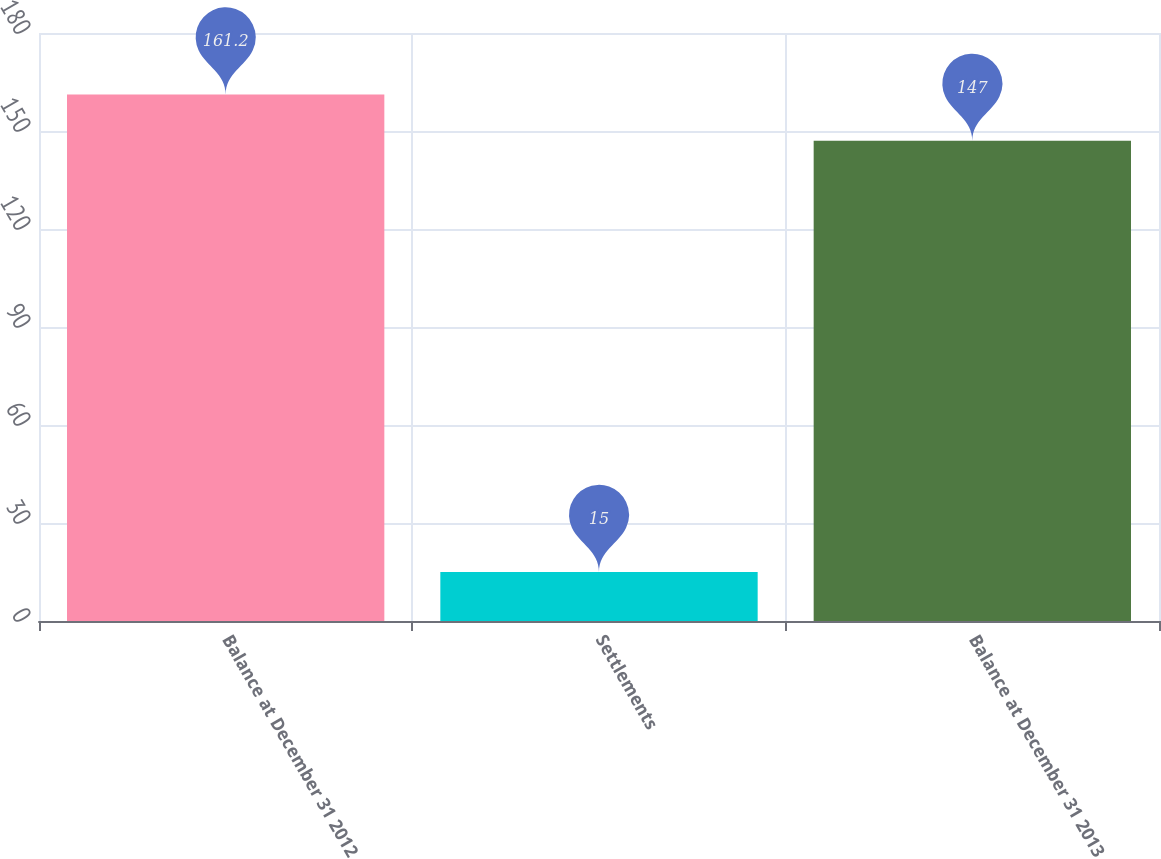<chart> <loc_0><loc_0><loc_500><loc_500><bar_chart><fcel>Balance at December 31 2012<fcel>Settlements<fcel>Balance at December 31 2013<nl><fcel>161.2<fcel>15<fcel>147<nl></chart> 